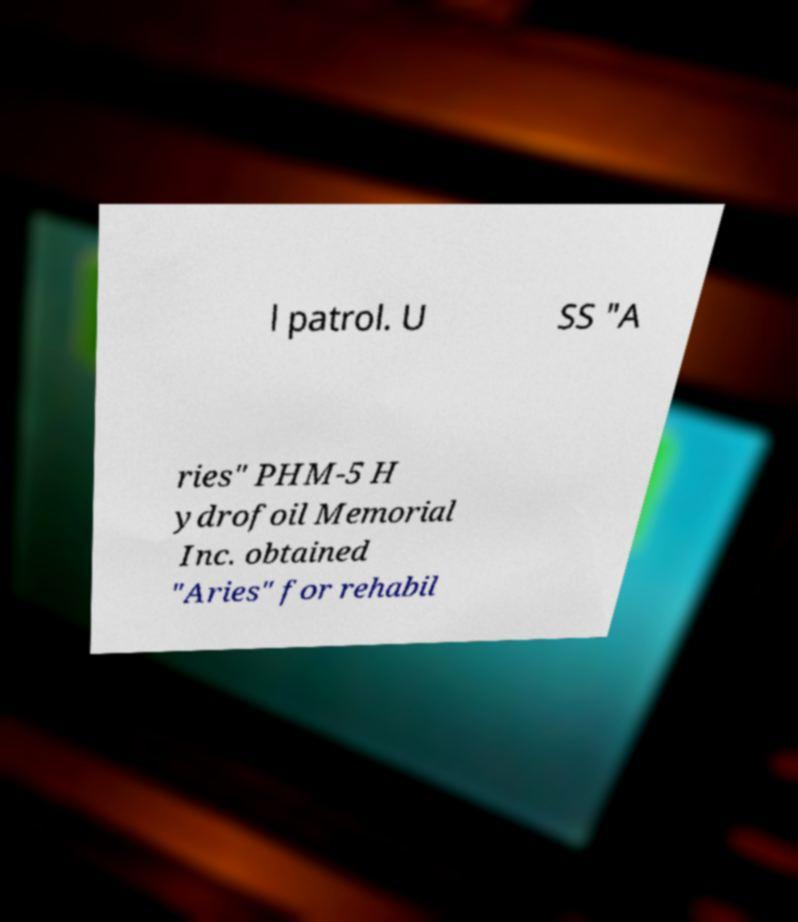There's text embedded in this image that I need extracted. Can you transcribe it verbatim? l patrol. U SS "A ries" PHM-5 H ydrofoil Memorial Inc. obtained "Aries" for rehabil 